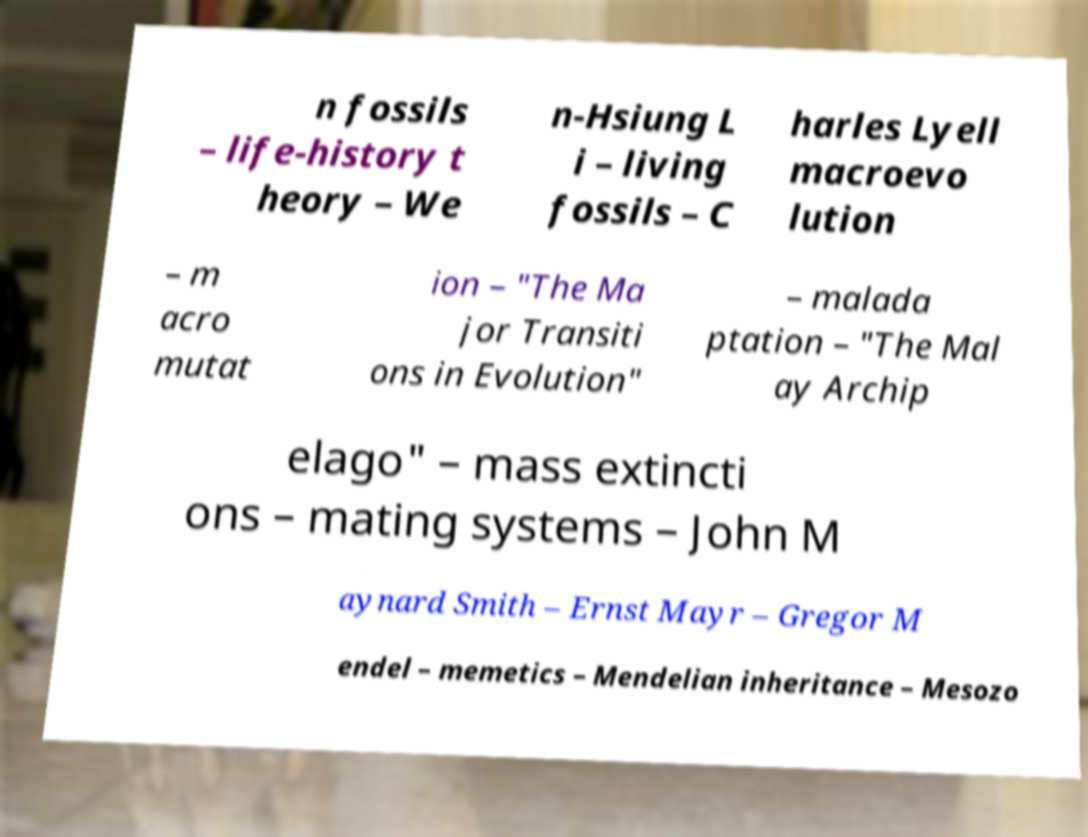Please identify and transcribe the text found in this image. n fossils – life-history t heory – We n-Hsiung L i – living fossils – C harles Lyell macroevo lution – m acro mutat ion – "The Ma jor Transiti ons in Evolution" – malada ptation – "The Mal ay Archip elago" – mass extincti ons – mating systems – John M aynard Smith – Ernst Mayr – Gregor M endel – memetics – Mendelian inheritance – Mesozo 